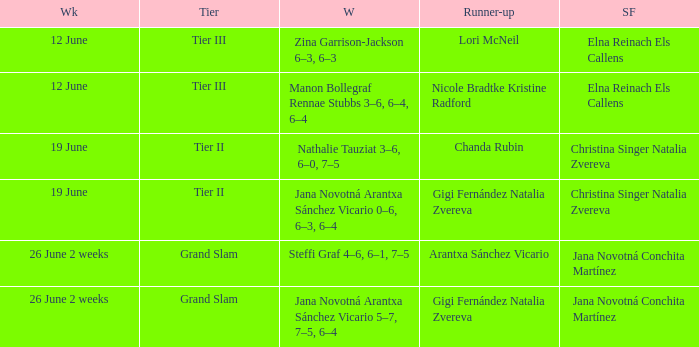In which week is the winner listed as Jana Novotná Arantxa Sánchez Vicario 5–7, 7–5, 6–4? 26 June 2 weeks. 